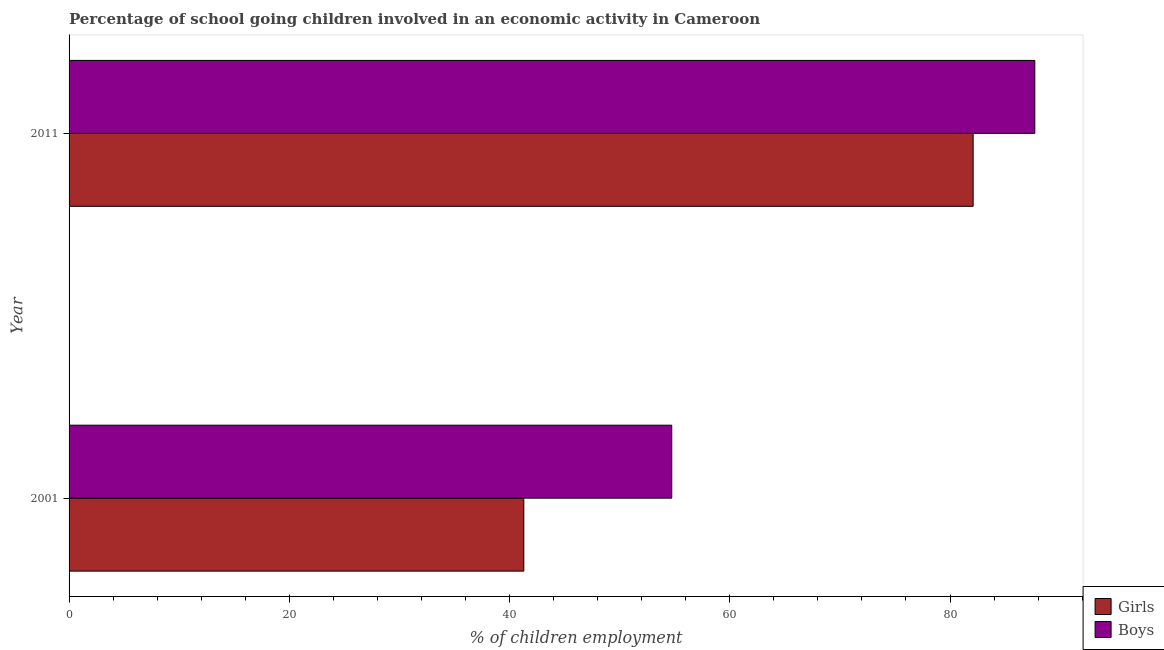How many different coloured bars are there?
Your response must be concise. 2. How many groups of bars are there?
Your answer should be compact. 2. Are the number of bars on each tick of the Y-axis equal?
Keep it short and to the point. Yes. How many bars are there on the 1st tick from the top?
Make the answer very short. 2. How many bars are there on the 1st tick from the bottom?
Offer a terse response. 2. What is the label of the 2nd group of bars from the top?
Keep it short and to the point. 2001. What is the percentage of school going girls in 2011?
Offer a very short reply. 82.1. Across all years, what is the maximum percentage of school going boys?
Offer a terse response. 87.7. Across all years, what is the minimum percentage of school going boys?
Keep it short and to the point. 54.73. In which year was the percentage of school going boys minimum?
Provide a short and direct response. 2001. What is the total percentage of school going boys in the graph?
Provide a succinct answer. 142.43. What is the difference between the percentage of school going boys in 2001 and that in 2011?
Offer a very short reply. -32.97. What is the difference between the percentage of school going girls in 2011 and the percentage of school going boys in 2001?
Your response must be concise. 27.37. What is the average percentage of school going boys per year?
Offer a very short reply. 71.22. In the year 2001, what is the difference between the percentage of school going boys and percentage of school going girls?
Your answer should be compact. 13.43. In how many years, is the percentage of school going girls greater than 88 %?
Provide a short and direct response. 0. What is the ratio of the percentage of school going girls in 2001 to that in 2011?
Give a very brief answer. 0.5. Is the percentage of school going girls in 2001 less than that in 2011?
Offer a very short reply. Yes. Is the difference between the percentage of school going boys in 2001 and 2011 greater than the difference between the percentage of school going girls in 2001 and 2011?
Provide a short and direct response. Yes. What does the 1st bar from the top in 2001 represents?
Your response must be concise. Boys. What does the 1st bar from the bottom in 2011 represents?
Your answer should be very brief. Girls. How many years are there in the graph?
Keep it short and to the point. 2. Does the graph contain grids?
Offer a terse response. No. Where does the legend appear in the graph?
Your answer should be very brief. Bottom right. What is the title of the graph?
Offer a very short reply. Percentage of school going children involved in an economic activity in Cameroon. Does "Forest land" appear as one of the legend labels in the graph?
Provide a succinct answer. No. What is the label or title of the X-axis?
Offer a terse response. % of children employment. What is the % of children employment in Girls in 2001?
Offer a very short reply. 41.3. What is the % of children employment in Boys in 2001?
Keep it short and to the point. 54.73. What is the % of children employment of Girls in 2011?
Ensure brevity in your answer.  82.1. What is the % of children employment in Boys in 2011?
Keep it short and to the point. 87.7. Across all years, what is the maximum % of children employment of Girls?
Make the answer very short. 82.1. Across all years, what is the maximum % of children employment of Boys?
Ensure brevity in your answer.  87.7. Across all years, what is the minimum % of children employment in Girls?
Your answer should be very brief. 41.3. Across all years, what is the minimum % of children employment in Boys?
Provide a succinct answer. 54.73. What is the total % of children employment in Girls in the graph?
Provide a short and direct response. 123.4. What is the total % of children employment in Boys in the graph?
Offer a terse response. 142.43. What is the difference between the % of children employment of Girls in 2001 and that in 2011?
Offer a terse response. -40.8. What is the difference between the % of children employment of Boys in 2001 and that in 2011?
Provide a short and direct response. -32.97. What is the difference between the % of children employment of Girls in 2001 and the % of children employment of Boys in 2011?
Keep it short and to the point. -46.4. What is the average % of children employment of Girls per year?
Your response must be concise. 61.7. What is the average % of children employment in Boys per year?
Ensure brevity in your answer.  71.21. In the year 2001, what is the difference between the % of children employment of Girls and % of children employment of Boys?
Offer a very short reply. -13.43. What is the ratio of the % of children employment of Girls in 2001 to that in 2011?
Provide a short and direct response. 0.5. What is the ratio of the % of children employment in Boys in 2001 to that in 2011?
Offer a very short reply. 0.62. What is the difference between the highest and the second highest % of children employment of Girls?
Offer a terse response. 40.8. What is the difference between the highest and the second highest % of children employment of Boys?
Keep it short and to the point. 32.97. What is the difference between the highest and the lowest % of children employment in Girls?
Ensure brevity in your answer.  40.8. What is the difference between the highest and the lowest % of children employment in Boys?
Give a very brief answer. 32.97. 